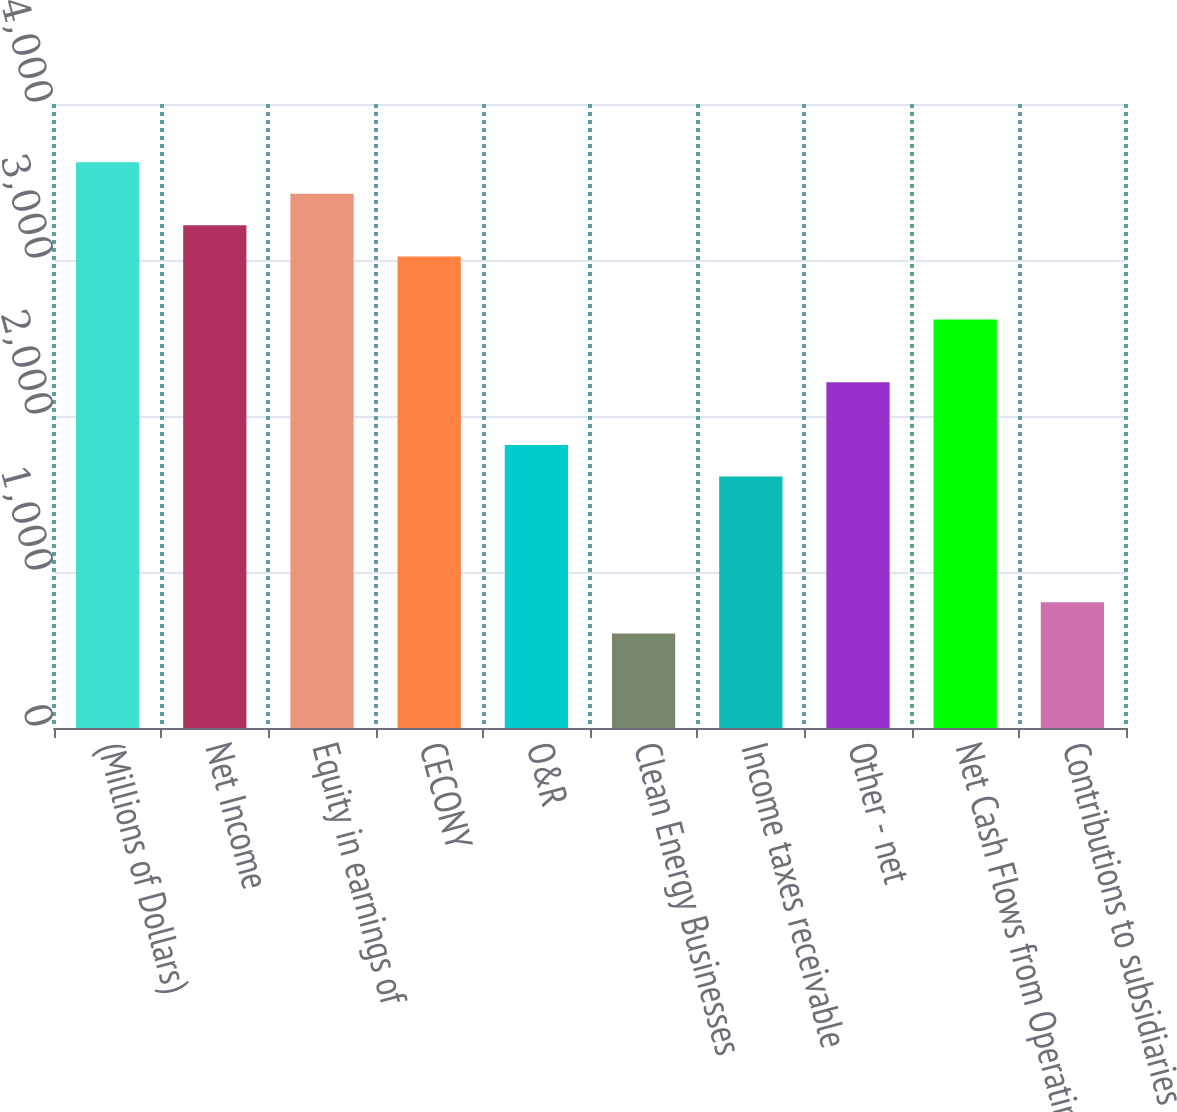Convert chart. <chart><loc_0><loc_0><loc_500><loc_500><bar_chart><fcel>(Millions of Dollars)<fcel>Net Income<fcel>Equity in earnings of<fcel>CECONY<fcel>O&R<fcel>Clean Energy Businesses<fcel>Income taxes receivable<fcel>Other - net<fcel>Net Cash Flows from Operating<fcel>Contributions to subsidiaries<nl><fcel>3626.2<fcel>3223.4<fcel>3424.8<fcel>3022<fcel>1813.6<fcel>605.2<fcel>1612.2<fcel>2216.4<fcel>2619.2<fcel>806.6<nl></chart> 